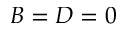Convert formula to latex. <formula><loc_0><loc_0><loc_500><loc_500>B = D = 0</formula> 